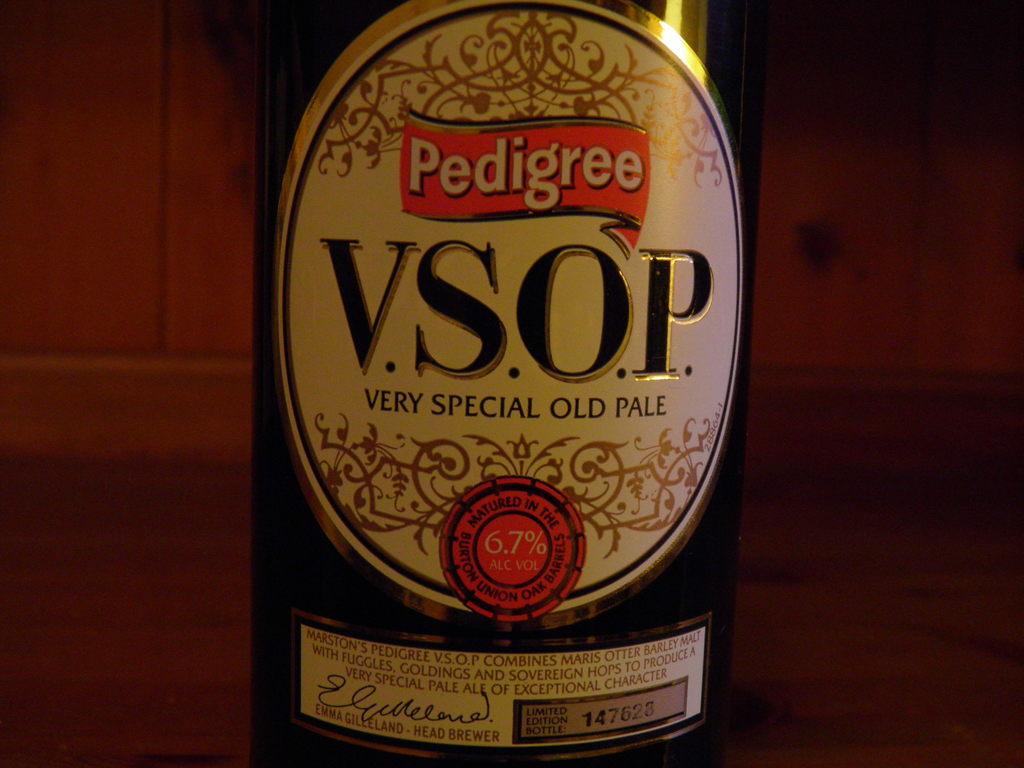What brand is that?
Keep it short and to the point. Pedigree. According to the bottle it is very special what?
Offer a terse response. Old pale. 